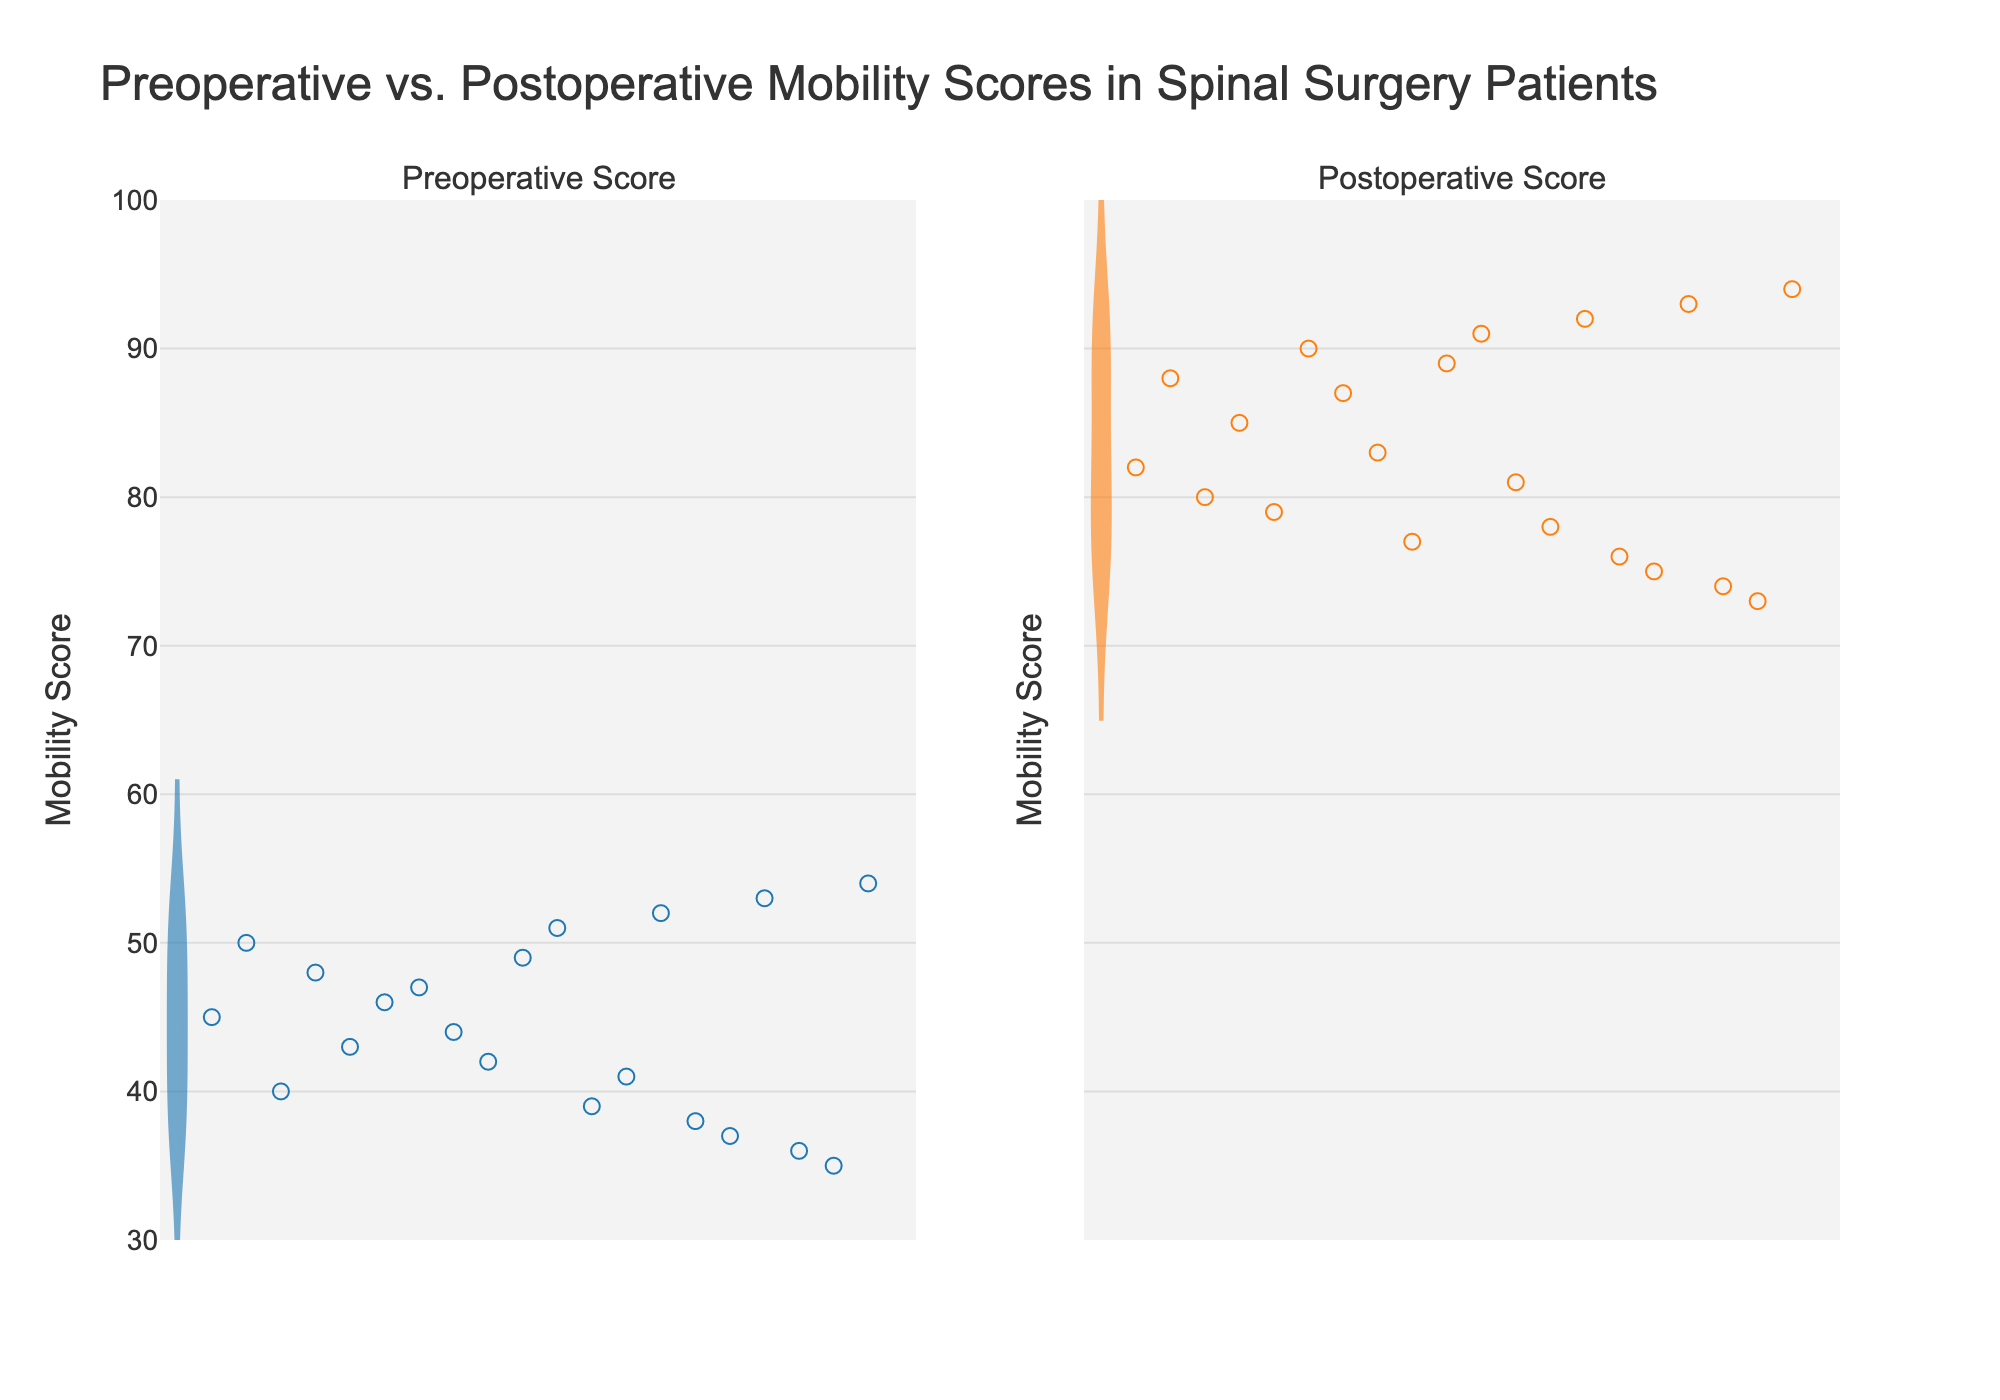How many subplots are there? The figure contains two subplots titled "Preoperative Score" and "Postoperative Score". Each title indicates a distinct Violin chart representing preoperative and postoperative mobility scores, respectively.
Answer: 2 What is the range of the y-axis? The y-axis is labeled "Mobility Score" and ranges from 30 to 100. This is evident from the tick marks on the y-axis.
Answer: 30 to 100 Which group has higher mobility scores, preoperative or postoperative? Comparing the two violin plots, the postoperative group generally shows higher scores as the distribution is shifted towards the upper end of the y-axis compared to the preoperative group.
Answer: Postoperative What is the title of the figure? The figure's title is "Preoperative vs. Postoperative Mobility Scores in Spinal Surgery Patients".
Answer: Preoperative vs. Postoperative Mobility Scores in Spinal Surgery Patients How can you tell which points belong to preoperative and postoperative groups? The points for the preoperative group are marked in blue, while those for the postoperative group are marked in orange. The Violin plots and jittered points share these color schemes, making it visually distinguishable.
Answer: By their colors (Blue for Preoperative, Orange for Postoperative) Are there more data points above a score of 80 in the preoperative group or the postoperative group? Visually comparing the number of jittered points in the two groups, there are more points above a score of 80 in the postoperative group than in the preoperative group.
Answer: Postoperative How can you describe the spread of scores in the preoperative versus postoperative groups? The postoperative group shows a more concentrated distribution with more scores closer to the higher end, while the preoperative group has a wider spread with more variance. This can be inferred from the shapes and widths of the violin plots.
Answer: Postoperative is more concentrated; preoperative is more spread out What are the colors of the violin plots for each group? The preoperative group's violin plot is blue, and the postoperative group's violin plot is orange.
Answer: Blue, Orange What visual elements indicate the interquartile range (IQR) in the violin plots? The box within each violin plot represents the interquartile range, with the boundaries of the box showing the 25th and 75th percentiles, while the line inside the box marks the median.
Answer: The box inside the plots Considering the y-axis range and the distribution shown in the violin plots, which group shows a more significant improvement in mobility scores? The postoperative group's scores are predominantly higher than the preoperative group's scores, indicating a significant improvement in mobility scores after surgery. This can be seen in the shift of the distribution towards the upper end of the y-axis.
Answer: Postoperative 